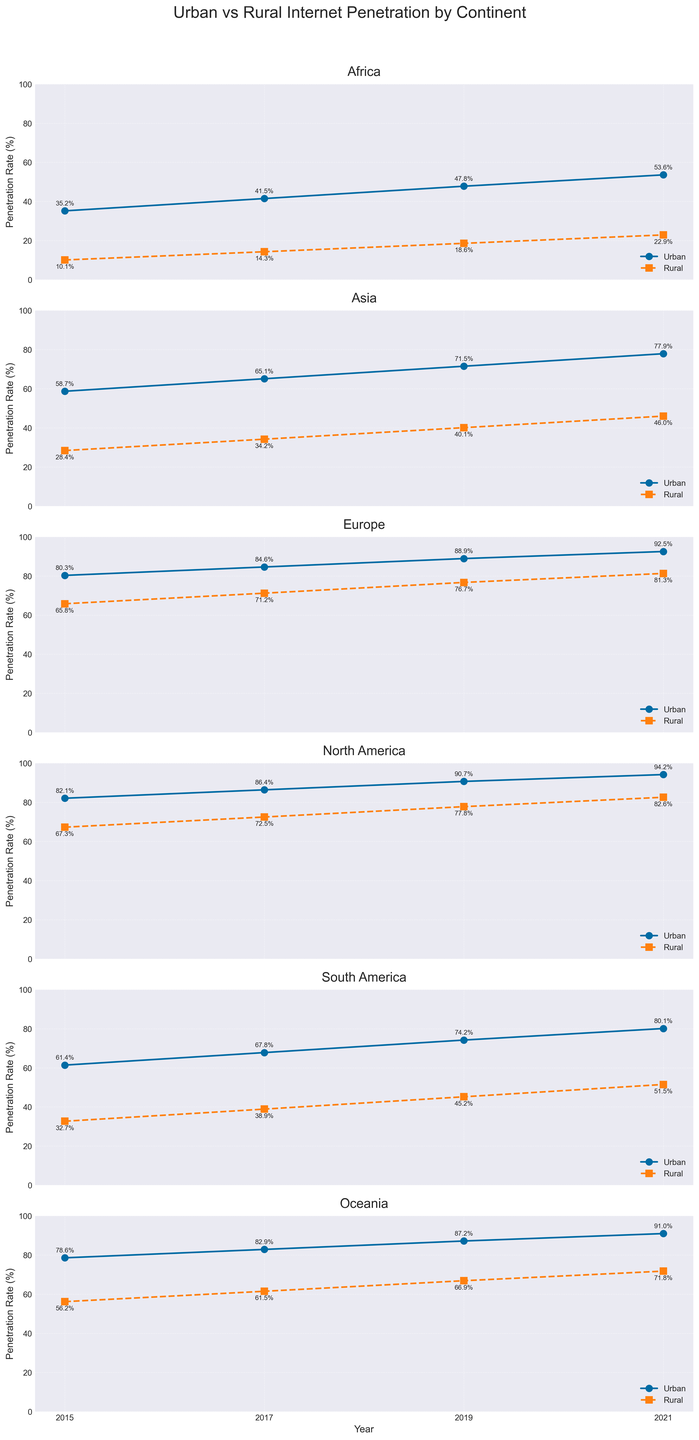Which continent has the highest rural internet penetration rate in 2021? To determine the continent with the highest rural internet penetration in 2021, we compare the rural rates for each continent in 2021. Europe has the highest value at 81.3%.
Answer: Europe How much did urban internet penetration in Asia increase from 2015 to 2021? Subtract the urban internet penetration rate of Asia in 2015 (58.7%) from the rate in 2021 (77.9%) to find the increase: 77.9% - 58.7% = 19.2%.
Answer: 19.2% Which continent shows the smallest difference between urban and rural internet penetration rates in 2019? For 2019, calculate the difference between urban and rural rates for each continent. For Europe, the difference is 88.9% - 76.7% = 12.2%. Comparisons show that Europe has the smallest difference (12.2%).
Answer: Europe In 2017, how much higher was urban internet penetration compared to rural internet penetration in Africa? Subtract the rural internet penetration rate in Africa for 2017 (14.3%) from the urban rate (41.5%) in the same year: 41.5% - 14.3% = 27.2%.
Answer: 27.2% Which continent has the most consistent growth in urban internet penetration from 2015 to 2021? Calculate the growth each year for urban rates and assess consistency. Africa’s urban penetration grows from 35.2%, 41.5%, 47.8%, to 53.6%, indicating steady and consistent increase year over year.
Answer: Africa How does rural internet penetration in South America in 2021 compare to that in North America in 2019? Compare the rural internet penetration rates: South America in 2021 has 51.5%, while North America in 2019 has 77.8%. South America's rate is lower.
Answer: South America is lower What is the average urban internet penetration rate in Oceania across the years available? Sum the urban rates for Oceania (78.6%, 82.9%, 87.2%, 91.0%) and divide by the number of years: (78.6 + 82.9 + 87.2 + 91.0) / 4 = 84.925%.
Answer: 84.9% Between 2015 and 2021, which continent shows the largest absolute increase in rural internet penetration? Calculate the increase for each continent. For Africa it is 22.9% - 10.1% = 12.8%, Asia 46.0% - 28.4% = 17.6%, Europe 81.3% - 65.8% = 15.5%, North America 82.6% - 67.3% = 15.3%, South America 51.5% - 32.7% = 18.8%, and Oceania 71.8% - 56.2% = 15.6%. South America shows the largest increase (18.8%).
Answer: South America Which year shows the greatest jump in urban internet penetration for Europe? Compare the year-on-year increment: from 2015 to 2017 (84.6% - 80.3% = 4.3%), 2017 to 2019 (88.9% - 84.6% = 4.3%), 2019 to 2021 (92.5% - 88.9% = 3.6%). The greatest jump is between 2015 and 2017.
Answer: 2015 to 2017 